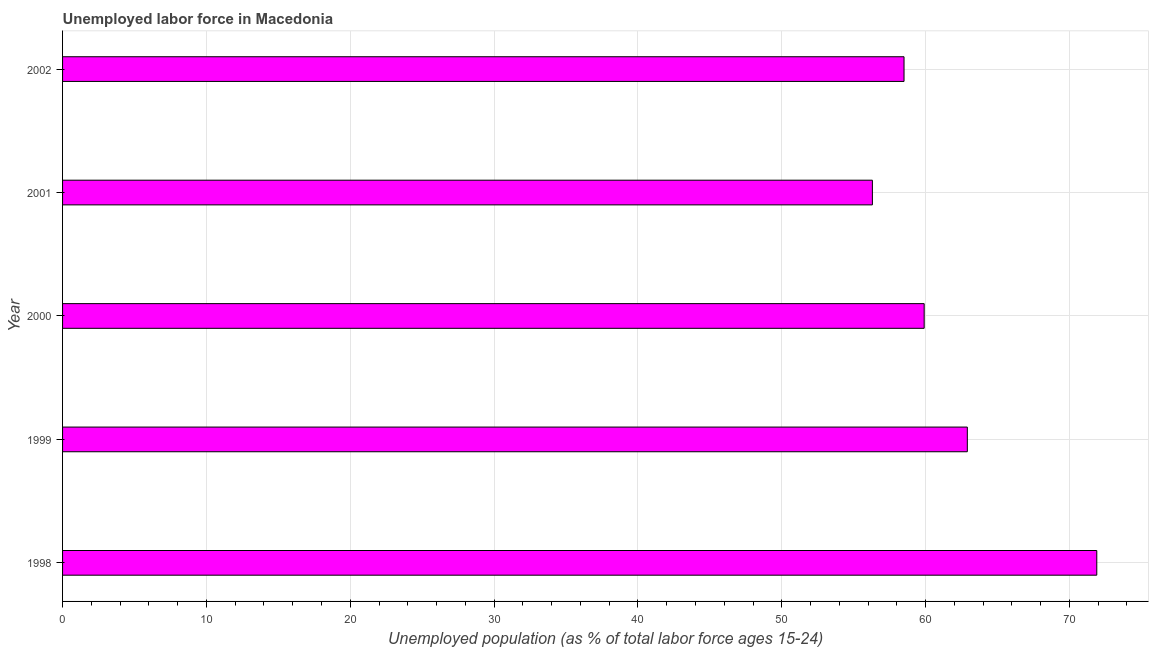Does the graph contain any zero values?
Offer a terse response. No. Does the graph contain grids?
Keep it short and to the point. Yes. What is the title of the graph?
Your answer should be compact. Unemployed labor force in Macedonia. What is the label or title of the X-axis?
Keep it short and to the point. Unemployed population (as % of total labor force ages 15-24). What is the label or title of the Y-axis?
Ensure brevity in your answer.  Year. What is the total unemployed youth population in 2002?
Offer a very short reply. 58.5. Across all years, what is the maximum total unemployed youth population?
Ensure brevity in your answer.  71.9. Across all years, what is the minimum total unemployed youth population?
Ensure brevity in your answer.  56.3. In which year was the total unemployed youth population minimum?
Ensure brevity in your answer.  2001. What is the sum of the total unemployed youth population?
Provide a short and direct response. 309.5. What is the average total unemployed youth population per year?
Offer a terse response. 61.9. What is the median total unemployed youth population?
Your answer should be compact. 59.9. In how many years, is the total unemployed youth population greater than 40 %?
Your answer should be very brief. 5. What is the ratio of the total unemployed youth population in 1998 to that in 2001?
Offer a very short reply. 1.28. Is the difference between the total unemployed youth population in 1998 and 2002 greater than the difference between any two years?
Your answer should be very brief. No. Is the sum of the total unemployed youth population in 1998 and 2002 greater than the maximum total unemployed youth population across all years?
Ensure brevity in your answer.  Yes. What is the difference between the highest and the lowest total unemployed youth population?
Offer a very short reply. 15.6. In how many years, is the total unemployed youth population greater than the average total unemployed youth population taken over all years?
Offer a terse response. 2. How many bars are there?
Make the answer very short. 5. Are all the bars in the graph horizontal?
Your answer should be very brief. Yes. How many years are there in the graph?
Ensure brevity in your answer.  5. What is the Unemployed population (as % of total labor force ages 15-24) of 1998?
Provide a succinct answer. 71.9. What is the Unemployed population (as % of total labor force ages 15-24) in 1999?
Your response must be concise. 62.9. What is the Unemployed population (as % of total labor force ages 15-24) of 2000?
Keep it short and to the point. 59.9. What is the Unemployed population (as % of total labor force ages 15-24) of 2001?
Give a very brief answer. 56.3. What is the Unemployed population (as % of total labor force ages 15-24) of 2002?
Your answer should be very brief. 58.5. What is the difference between the Unemployed population (as % of total labor force ages 15-24) in 1998 and 1999?
Make the answer very short. 9. What is the difference between the Unemployed population (as % of total labor force ages 15-24) in 1998 and 2000?
Offer a terse response. 12. What is the difference between the Unemployed population (as % of total labor force ages 15-24) in 1998 and 2001?
Provide a short and direct response. 15.6. What is the difference between the Unemployed population (as % of total labor force ages 15-24) in 1998 and 2002?
Your answer should be very brief. 13.4. What is the difference between the Unemployed population (as % of total labor force ages 15-24) in 1999 and 2000?
Ensure brevity in your answer.  3. What is the difference between the Unemployed population (as % of total labor force ages 15-24) in 2001 and 2002?
Give a very brief answer. -2.2. What is the ratio of the Unemployed population (as % of total labor force ages 15-24) in 1998 to that in 1999?
Ensure brevity in your answer.  1.14. What is the ratio of the Unemployed population (as % of total labor force ages 15-24) in 1998 to that in 2000?
Keep it short and to the point. 1.2. What is the ratio of the Unemployed population (as % of total labor force ages 15-24) in 1998 to that in 2001?
Ensure brevity in your answer.  1.28. What is the ratio of the Unemployed population (as % of total labor force ages 15-24) in 1998 to that in 2002?
Your answer should be compact. 1.23. What is the ratio of the Unemployed population (as % of total labor force ages 15-24) in 1999 to that in 2000?
Keep it short and to the point. 1.05. What is the ratio of the Unemployed population (as % of total labor force ages 15-24) in 1999 to that in 2001?
Make the answer very short. 1.12. What is the ratio of the Unemployed population (as % of total labor force ages 15-24) in 1999 to that in 2002?
Give a very brief answer. 1.07. What is the ratio of the Unemployed population (as % of total labor force ages 15-24) in 2000 to that in 2001?
Keep it short and to the point. 1.06. What is the ratio of the Unemployed population (as % of total labor force ages 15-24) in 2000 to that in 2002?
Provide a short and direct response. 1.02. What is the ratio of the Unemployed population (as % of total labor force ages 15-24) in 2001 to that in 2002?
Ensure brevity in your answer.  0.96. 